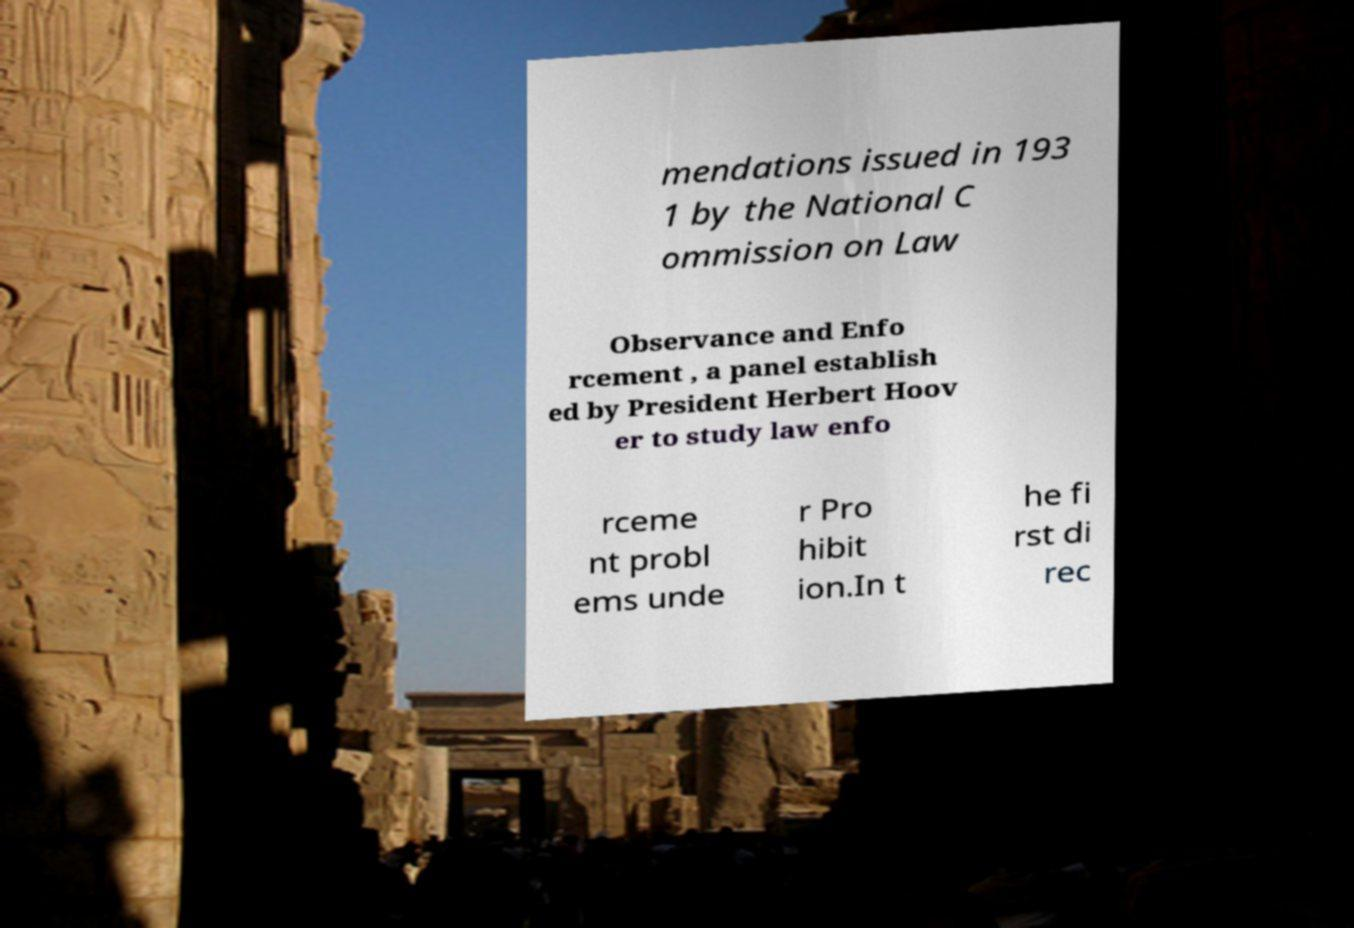Please read and relay the text visible in this image. What does it say? mendations issued in 193 1 by the National C ommission on Law Observance and Enfo rcement , a panel establish ed by President Herbert Hoov er to study law enfo rceme nt probl ems unde r Pro hibit ion.In t he fi rst di rec 